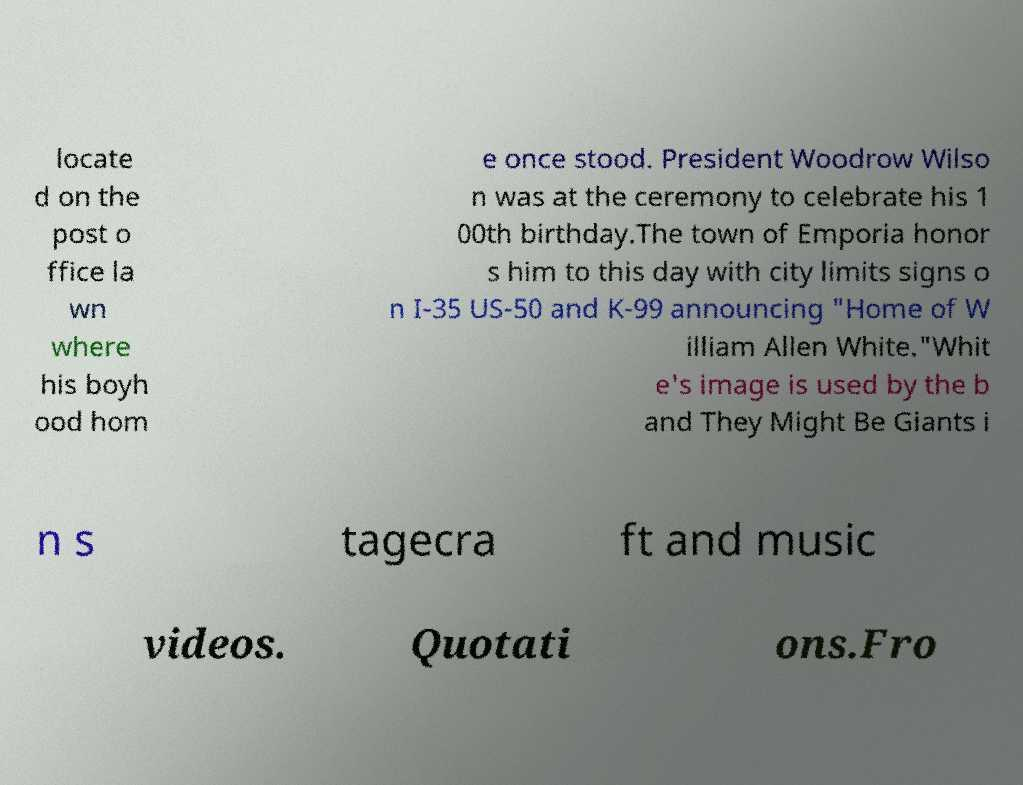Could you assist in decoding the text presented in this image and type it out clearly? locate d on the post o ffice la wn where his boyh ood hom e once stood. President Woodrow Wilso n was at the ceremony to celebrate his 1 00th birthday.The town of Emporia honor s him to this day with city limits signs o n I-35 US-50 and K-99 announcing "Home of W illiam Allen White."Whit e's image is used by the b and They Might Be Giants i n s tagecra ft and music videos. Quotati ons.Fro 